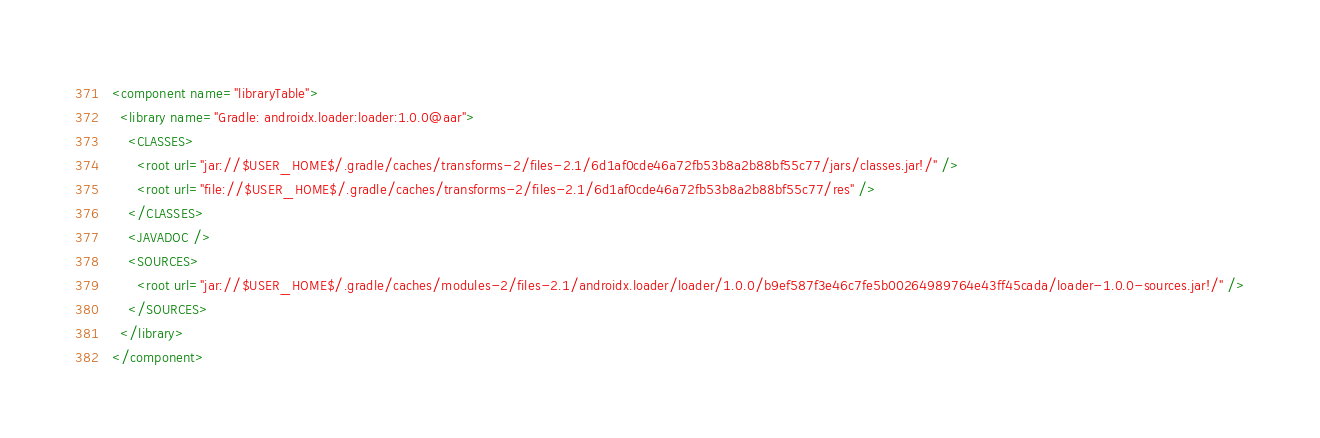Convert code to text. <code><loc_0><loc_0><loc_500><loc_500><_XML_><component name="libraryTable">
  <library name="Gradle: androidx.loader:loader:1.0.0@aar">
    <CLASSES>
      <root url="jar://$USER_HOME$/.gradle/caches/transforms-2/files-2.1/6d1af0cde46a72fb53b8a2b88bf55c77/jars/classes.jar!/" />
      <root url="file://$USER_HOME$/.gradle/caches/transforms-2/files-2.1/6d1af0cde46a72fb53b8a2b88bf55c77/res" />
    </CLASSES>
    <JAVADOC />
    <SOURCES>
      <root url="jar://$USER_HOME$/.gradle/caches/modules-2/files-2.1/androidx.loader/loader/1.0.0/b9ef587f3e46c7fe5b00264989764e43ff45cada/loader-1.0.0-sources.jar!/" />
    </SOURCES>
  </library>
</component></code> 